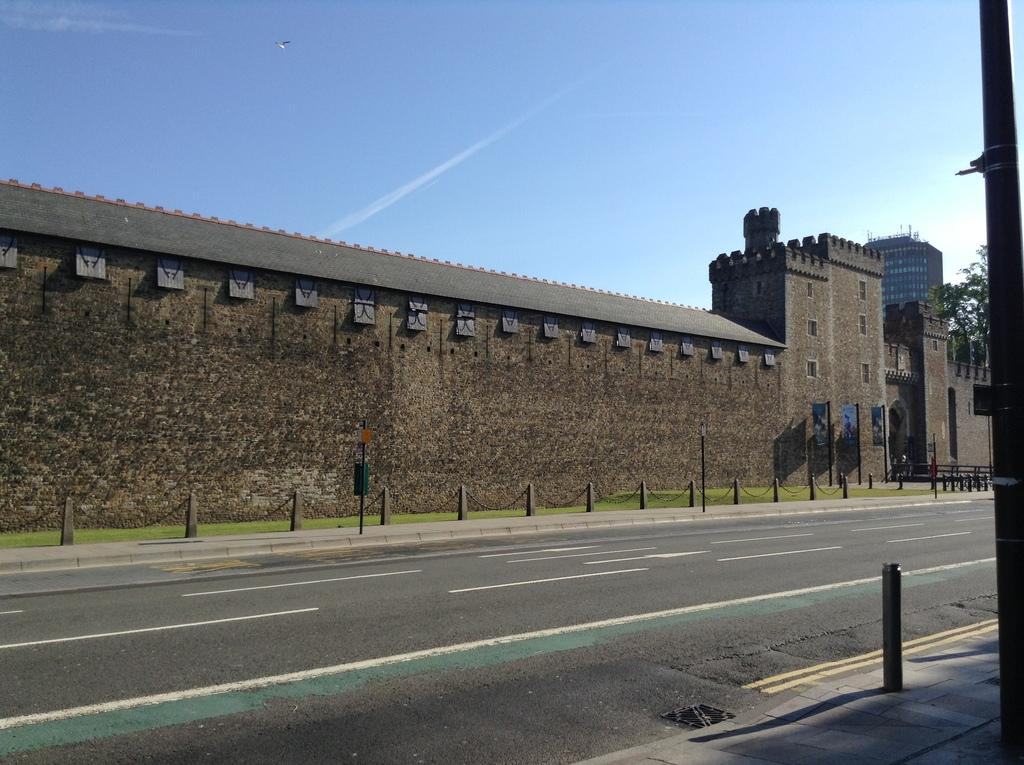What is located in the front of the image? There is a road in the front of the image. What type of barrier can be seen in the image? There is fencing in the image. What type of structure is present in the image? There is a brick wall in the image. Does the brick wall have a rooftop? Yes, the brick wall has a rooftop. Can you tell me how many sisters are visible in the image? There are no sisters present in the image. Is there a beggar asking for credit in the image? There is no beggar or mention of credit in the image. 